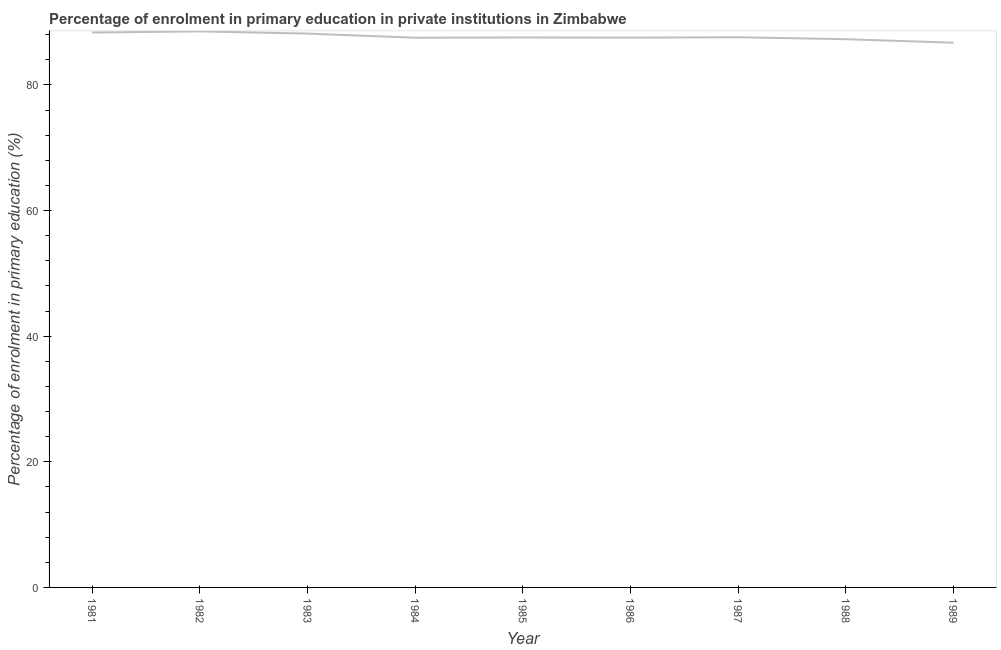What is the enrolment percentage in primary education in 1984?
Keep it short and to the point. 87.52. Across all years, what is the maximum enrolment percentage in primary education?
Ensure brevity in your answer.  88.53. Across all years, what is the minimum enrolment percentage in primary education?
Your answer should be compact. 86.73. In which year was the enrolment percentage in primary education maximum?
Your answer should be compact. 1982. What is the sum of the enrolment percentage in primary education?
Your answer should be compact. 789.3. What is the difference between the enrolment percentage in primary education in 1982 and 1987?
Offer a very short reply. 0.93. What is the average enrolment percentage in primary education per year?
Your answer should be compact. 87.7. What is the median enrolment percentage in primary education?
Your response must be concise. 87.57. What is the ratio of the enrolment percentage in primary education in 1985 to that in 1986?
Ensure brevity in your answer.  1. Is the enrolment percentage in primary education in 1983 less than that in 1984?
Your answer should be very brief. No. What is the difference between the highest and the second highest enrolment percentage in primary education?
Your response must be concise. 0.18. Is the sum of the enrolment percentage in primary education in 1984 and 1987 greater than the maximum enrolment percentage in primary education across all years?
Give a very brief answer. Yes. What is the difference between the highest and the lowest enrolment percentage in primary education?
Your answer should be very brief. 1.8. In how many years, is the enrolment percentage in primary education greater than the average enrolment percentage in primary education taken over all years?
Your answer should be very brief. 3. Does the enrolment percentage in primary education monotonically increase over the years?
Offer a terse response. No. What is the difference between two consecutive major ticks on the Y-axis?
Your answer should be very brief. 20. Are the values on the major ticks of Y-axis written in scientific E-notation?
Offer a very short reply. No. What is the title of the graph?
Your answer should be very brief. Percentage of enrolment in primary education in private institutions in Zimbabwe. What is the label or title of the X-axis?
Your answer should be compact. Year. What is the label or title of the Y-axis?
Your response must be concise. Percentage of enrolment in primary education (%). What is the Percentage of enrolment in primary education (%) of 1981?
Offer a terse response. 88.35. What is the Percentage of enrolment in primary education (%) of 1982?
Offer a terse response. 88.53. What is the Percentage of enrolment in primary education (%) in 1983?
Your response must be concise. 88.18. What is the Percentage of enrolment in primary education (%) of 1984?
Keep it short and to the point. 87.52. What is the Percentage of enrolment in primary education (%) in 1985?
Give a very brief answer. 87.57. What is the Percentage of enrolment in primary education (%) in 1986?
Your response must be concise. 87.54. What is the Percentage of enrolment in primary education (%) of 1987?
Ensure brevity in your answer.  87.6. What is the Percentage of enrolment in primary education (%) in 1988?
Provide a short and direct response. 87.29. What is the Percentage of enrolment in primary education (%) of 1989?
Make the answer very short. 86.73. What is the difference between the Percentage of enrolment in primary education (%) in 1981 and 1982?
Provide a succinct answer. -0.18. What is the difference between the Percentage of enrolment in primary education (%) in 1981 and 1983?
Your response must be concise. 0.17. What is the difference between the Percentage of enrolment in primary education (%) in 1981 and 1984?
Provide a short and direct response. 0.83. What is the difference between the Percentage of enrolment in primary education (%) in 1981 and 1985?
Your response must be concise. 0.78. What is the difference between the Percentage of enrolment in primary education (%) in 1981 and 1986?
Offer a very short reply. 0.81. What is the difference between the Percentage of enrolment in primary education (%) in 1981 and 1987?
Your response must be concise. 0.75. What is the difference between the Percentage of enrolment in primary education (%) in 1981 and 1988?
Ensure brevity in your answer.  1.06. What is the difference between the Percentage of enrolment in primary education (%) in 1981 and 1989?
Your response must be concise. 1.62. What is the difference between the Percentage of enrolment in primary education (%) in 1982 and 1983?
Keep it short and to the point. 0.35. What is the difference between the Percentage of enrolment in primary education (%) in 1982 and 1984?
Your answer should be very brief. 1.01. What is the difference between the Percentage of enrolment in primary education (%) in 1982 and 1985?
Offer a very short reply. 0.97. What is the difference between the Percentage of enrolment in primary education (%) in 1982 and 1986?
Offer a very short reply. 0.99. What is the difference between the Percentage of enrolment in primary education (%) in 1982 and 1987?
Keep it short and to the point. 0.93. What is the difference between the Percentage of enrolment in primary education (%) in 1982 and 1988?
Offer a very short reply. 1.24. What is the difference between the Percentage of enrolment in primary education (%) in 1982 and 1989?
Provide a succinct answer. 1.8. What is the difference between the Percentage of enrolment in primary education (%) in 1983 and 1984?
Your response must be concise. 0.66. What is the difference between the Percentage of enrolment in primary education (%) in 1983 and 1985?
Offer a very short reply. 0.61. What is the difference between the Percentage of enrolment in primary education (%) in 1983 and 1986?
Offer a very short reply. 0.64. What is the difference between the Percentage of enrolment in primary education (%) in 1983 and 1987?
Your answer should be very brief. 0.58. What is the difference between the Percentage of enrolment in primary education (%) in 1983 and 1988?
Your answer should be compact. 0.89. What is the difference between the Percentage of enrolment in primary education (%) in 1983 and 1989?
Your response must be concise. 1.45. What is the difference between the Percentage of enrolment in primary education (%) in 1984 and 1985?
Provide a succinct answer. -0.04. What is the difference between the Percentage of enrolment in primary education (%) in 1984 and 1986?
Provide a succinct answer. -0.01. What is the difference between the Percentage of enrolment in primary education (%) in 1984 and 1987?
Offer a very short reply. -0.08. What is the difference between the Percentage of enrolment in primary education (%) in 1984 and 1988?
Offer a terse response. 0.23. What is the difference between the Percentage of enrolment in primary education (%) in 1984 and 1989?
Make the answer very short. 0.79. What is the difference between the Percentage of enrolment in primary education (%) in 1985 and 1986?
Keep it short and to the point. 0.03. What is the difference between the Percentage of enrolment in primary education (%) in 1985 and 1987?
Ensure brevity in your answer.  -0.03. What is the difference between the Percentage of enrolment in primary education (%) in 1985 and 1988?
Provide a succinct answer. 0.28. What is the difference between the Percentage of enrolment in primary education (%) in 1985 and 1989?
Give a very brief answer. 0.84. What is the difference between the Percentage of enrolment in primary education (%) in 1986 and 1987?
Provide a succinct answer. -0.06. What is the difference between the Percentage of enrolment in primary education (%) in 1986 and 1988?
Offer a terse response. 0.25. What is the difference between the Percentage of enrolment in primary education (%) in 1986 and 1989?
Keep it short and to the point. 0.81. What is the difference between the Percentage of enrolment in primary education (%) in 1987 and 1988?
Provide a short and direct response. 0.31. What is the difference between the Percentage of enrolment in primary education (%) in 1987 and 1989?
Your answer should be compact. 0.87. What is the difference between the Percentage of enrolment in primary education (%) in 1988 and 1989?
Your answer should be compact. 0.56. What is the ratio of the Percentage of enrolment in primary education (%) in 1981 to that in 1982?
Provide a short and direct response. 1. What is the ratio of the Percentage of enrolment in primary education (%) in 1981 to that in 1983?
Offer a very short reply. 1. What is the ratio of the Percentage of enrolment in primary education (%) in 1981 to that in 1988?
Provide a short and direct response. 1.01. What is the ratio of the Percentage of enrolment in primary education (%) in 1982 to that in 1984?
Provide a succinct answer. 1.01. What is the ratio of the Percentage of enrolment in primary education (%) in 1982 to that in 1987?
Offer a terse response. 1.01. What is the ratio of the Percentage of enrolment in primary education (%) in 1983 to that in 1986?
Offer a terse response. 1.01. What is the ratio of the Percentage of enrolment in primary education (%) in 1984 to that in 1986?
Your response must be concise. 1. What is the ratio of the Percentage of enrolment in primary education (%) in 1984 to that in 1987?
Your response must be concise. 1. What is the ratio of the Percentage of enrolment in primary education (%) in 1985 to that in 1988?
Offer a very short reply. 1. What is the ratio of the Percentage of enrolment in primary education (%) in 1986 to that in 1988?
Your response must be concise. 1. What is the ratio of the Percentage of enrolment in primary education (%) in 1987 to that in 1988?
Make the answer very short. 1. What is the ratio of the Percentage of enrolment in primary education (%) in 1987 to that in 1989?
Provide a succinct answer. 1.01. What is the ratio of the Percentage of enrolment in primary education (%) in 1988 to that in 1989?
Your response must be concise. 1.01. 